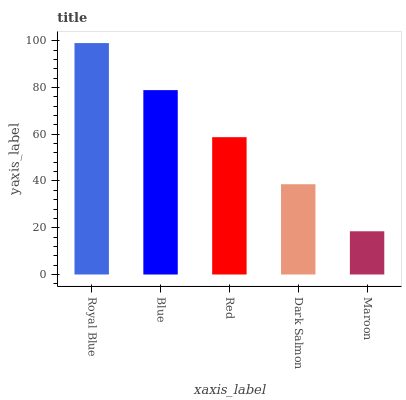Is Maroon the minimum?
Answer yes or no. Yes. Is Royal Blue the maximum?
Answer yes or no. Yes. Is Blue the minimum?
Answer yes or no. No. Is Blue the maximum?
Answer yes or no. No. Is Royal Blue greater than Blue?
Answer yes or no. Yes. Is Blue less than Royal Blue?
Answer yes or no. Yes. Is Blue greater than Royal Blue?
Answer yes or no. No. Is Royal Blue less than Blue?
Answer yes or no. No. Is Red the high median?
Answer yes or no. Yes. Is Red the low median?
Answer yes or no. Yes. Is Blue the high median?
Answer yes or no. No. Is Blue the low median?
Answer yes or no. No. 